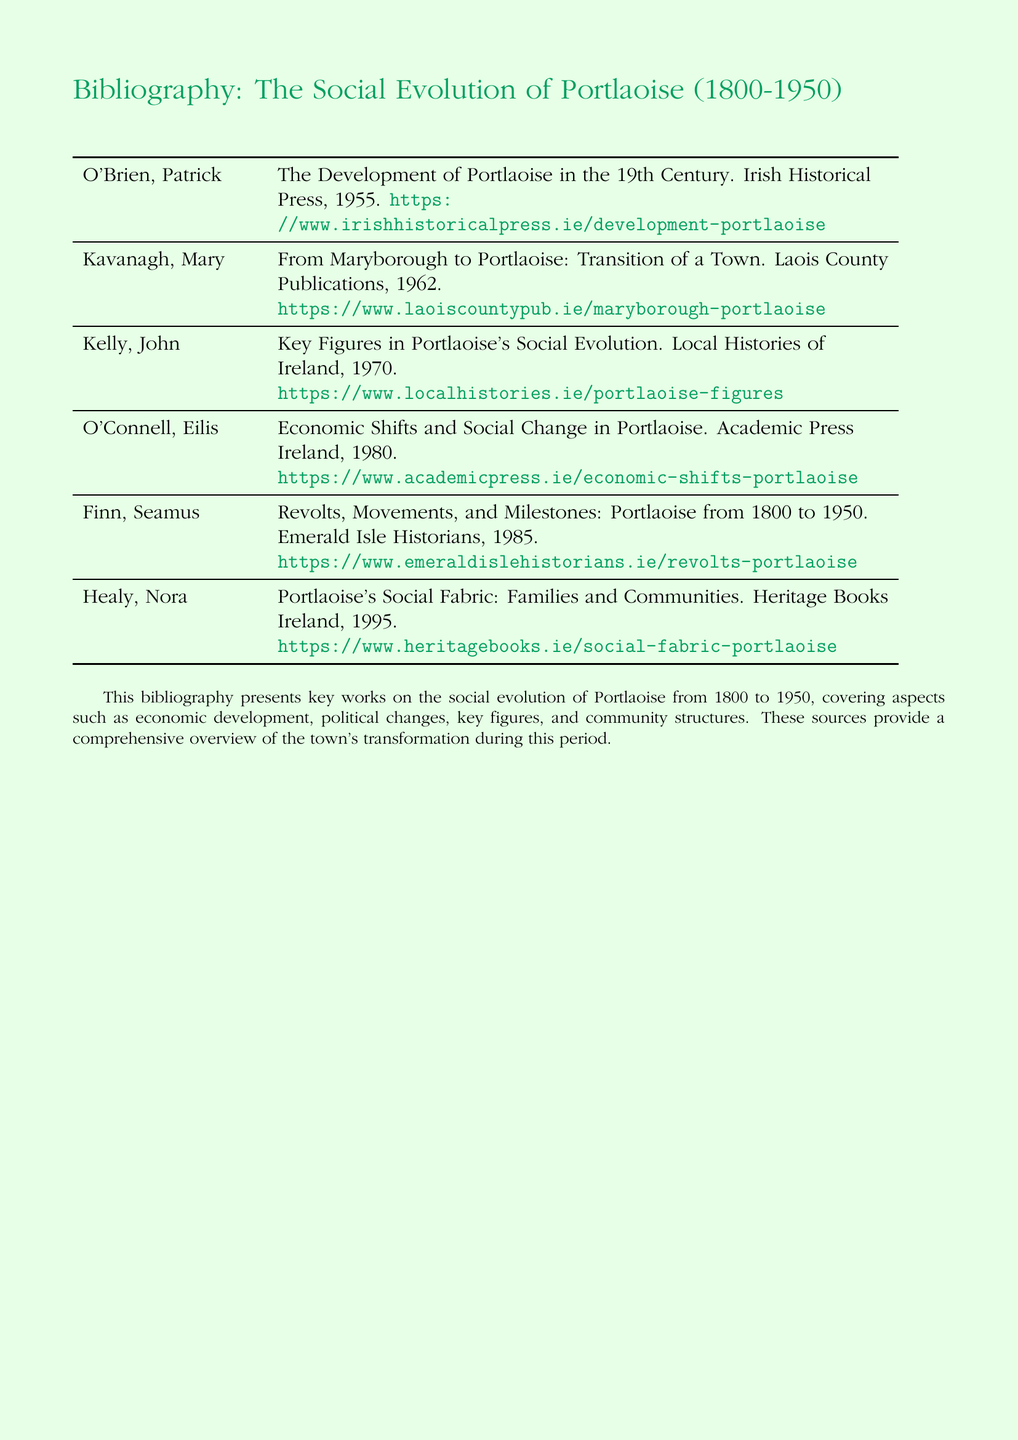What is the title of Patrick O'Brien's work? The title of the work by Patrick O'Brien is "The Development of Portlaoise in the 19th Century."
Answer: The Development of Portlaoise in the 19th Century Who published the work by Mary Kavanagh? The work by Mary Kavanagh was published by Laois County Publications.
Answer: Laois County Publications In which year was "Key Figures in Portlaoise's Social Evolution" published? "Key Figures in Portlaoise's Social Evolution" was published in 1970.
Answer: 1970 What is the main topic covered by Eilis O'Connell's book? Eilis O'Connell's book covers economic shifts and social change in Portlaoise.
Answer: Economic Shifts and Social Change Who is the author of "Revolts, Movements, and Milestones: Portlaoise from 1800 to 1950"? The author of the book is Seamus Finn.
Answer: Seamus Finn How many works are listed in the bibliography? There are six works listed in the bibliography.
Answer: Six Which publishing house released Nora Healy's work? Nora Healy's work was released by Heritage Books Ireland.
Answer: Heritage Books Ireland What period does the bibliography focus on? The bibliography focuses on the period from 1800 to 1950.
Answer: 1800 to 1950 